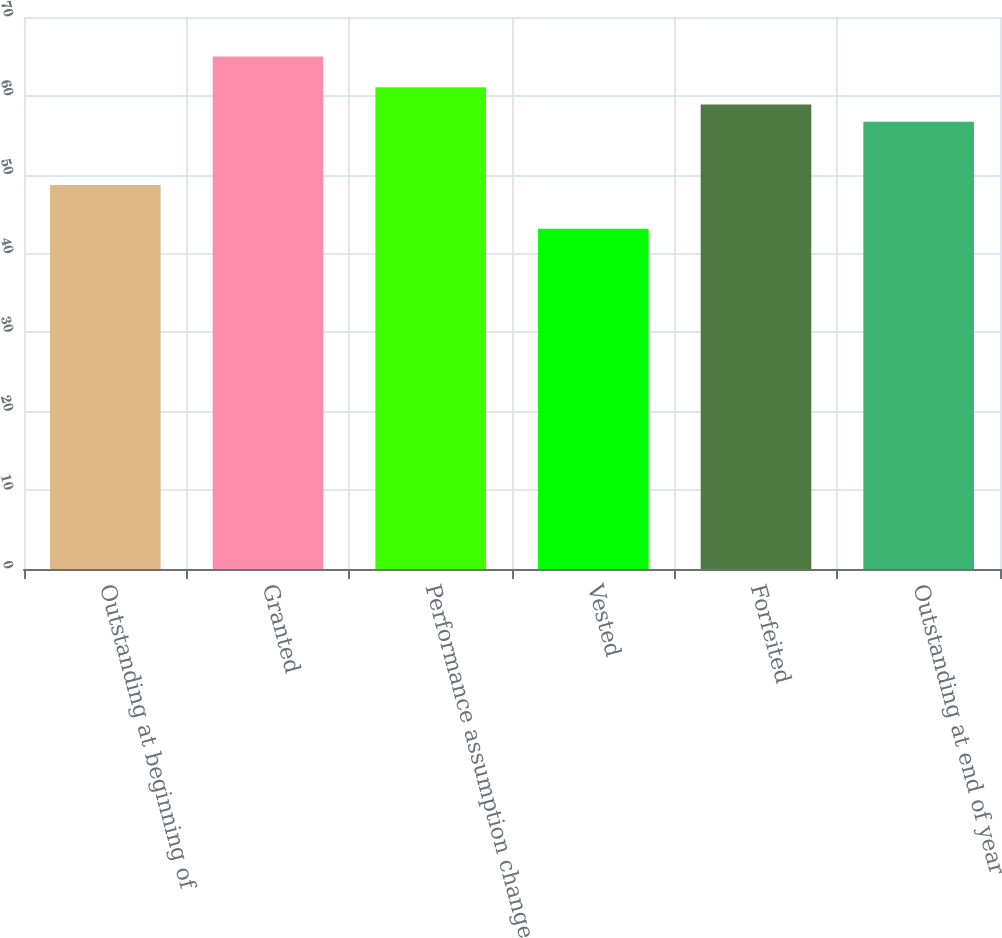Convert chart. <chart><loc_0><loc_0><loc_500><loc_500><bar_chart><fcel>Outstanding at beginning of<fcel>Granted<fcel>Performance assumption change<fcel>Vested<fcel>Forfeited<fcel>Outstanding at end of year<nl><fcel>48.7<fcel>64.99<fcel>61.09<fcel>43.14<fcel>58.9<fcel>56.71<nl></chart> 